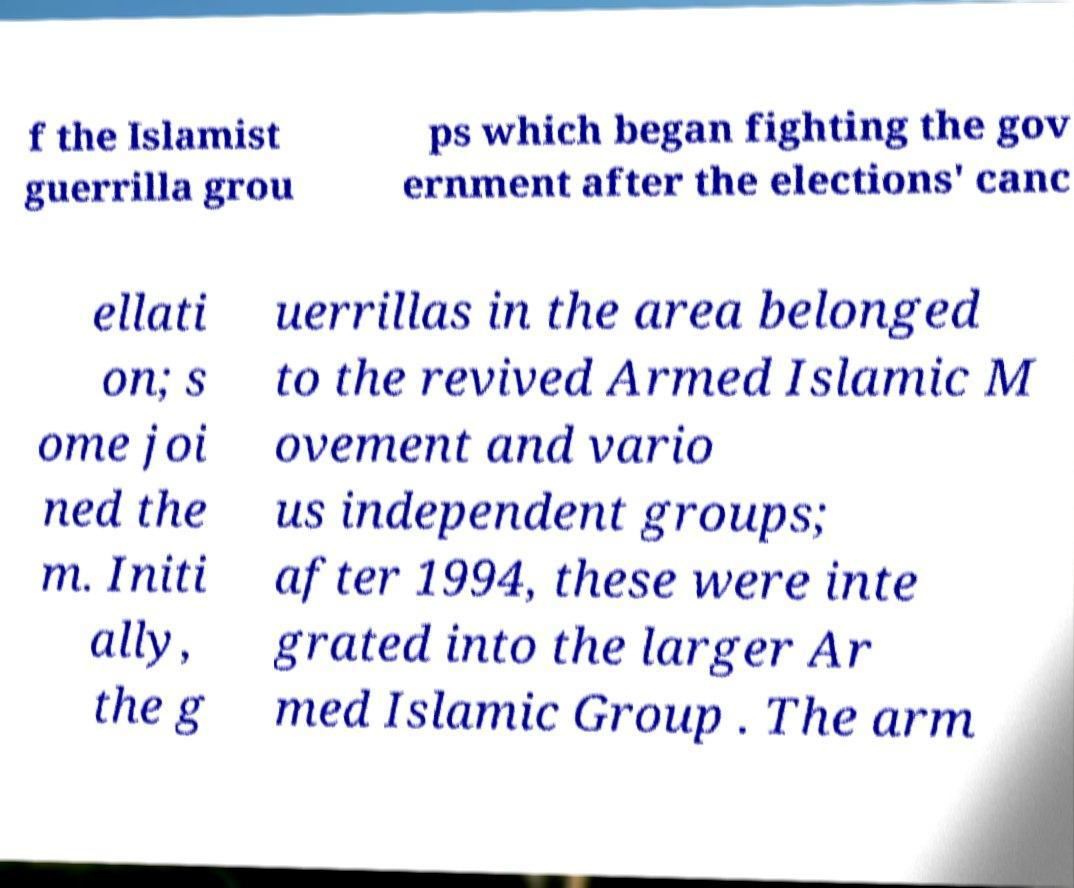What messages or text are displayed in this image? I need them in a readable, typed format. f the Islamist guerrilla grou ps which began fighting the gov ernment after the elections' canc ellati on; s ome joi ned the m. Initi ally, the g uerrillas in the area belonged to the revived Armed Islamic M ovement and vario us independent groups; after 1994, these were inte grated into the larger Ar med Islamic Group . The arm 